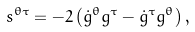<formula> <loc_0><loc_0><loc_500><loc_500>s ^ { \theta \tau } = - 2 \left ( \dot { g } ^ { \theta } g ^ { \tau } - \dot { g } ^ { \tau } g ^ { \theta } \right ) ,</formula> 